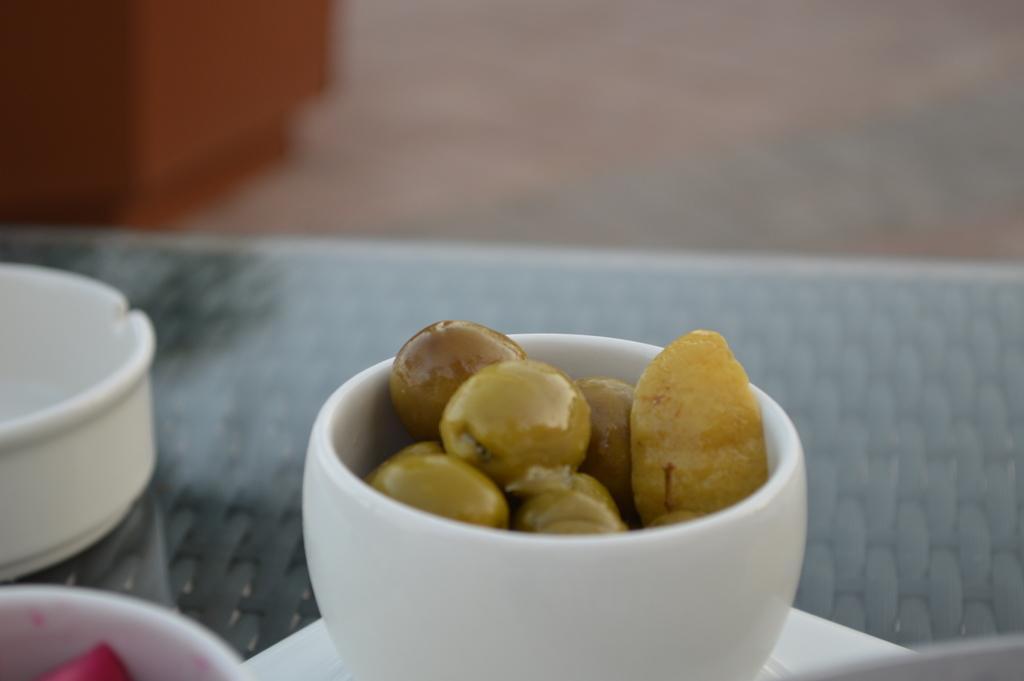Could you give a brief overview of what you see in this image? We can see bowls and food on the surface. In the background it is blur. 